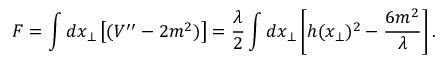<formula> <loc_0><loc_0><loc_500><loc_500>F = \int d x _ { \bot } \left [ ( V ^ { \prime \prime } - 2 m ^ { 2 } ) \right ] = \frac { \lambda } { 2 } \int d x _ { \bot } \left [ h ( x _ { \bot } ) ^ { 2 } - \frac { 6 m ^ { 2 } } { \lambda } \right ] .</formula> 